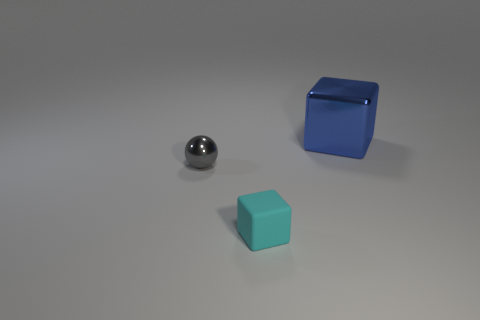Add 1 tiny spheres. How many objects exist? 4 Subtract all blocks. How many objects are left? 1 Subtract 0 cyan cylinders. How many objects are left? 3 Subtract all tiny metallic spheres. Subtract all yellow matte blocks. How many objects are left? 2 Add 1 large metallic blocks. How many large metallic blocks are left? 2 Add 1 tiny gray cylinders. How many tiny gray cylinders exist? 1 